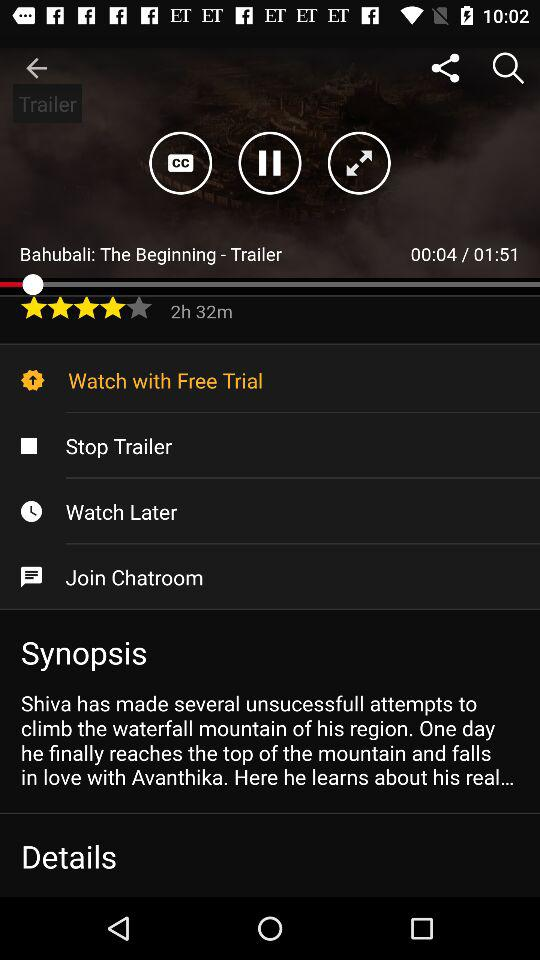How much of the "Bahubali: The Beginning-Trailer" has been finished? The "Bahubali: The Beginning-Trailer" has been finished up to 00:04. 